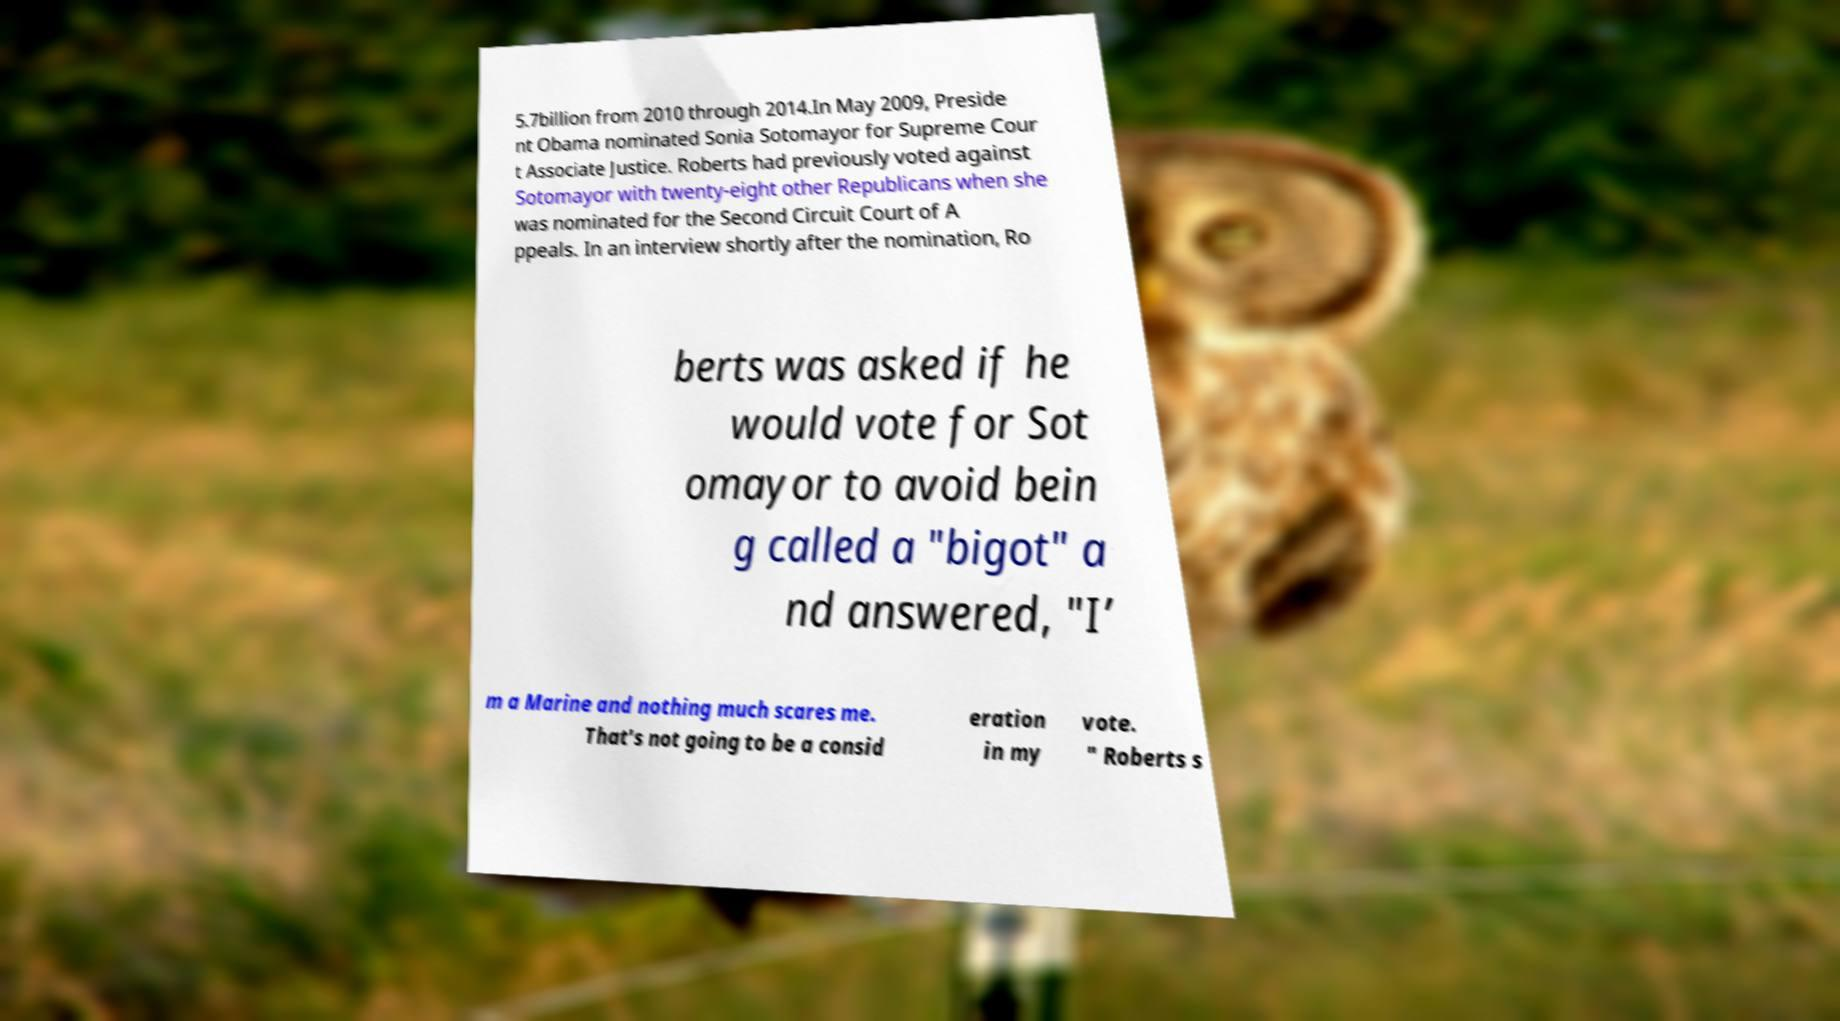Please read and relay the text visible in this image. What does it say? 5.7billion from 2010 through 2014.In May 2009, Preside nt Obama nominated Sonia Sotomayor for Supreme Cour t Associate Justice. Roberts had previously voted against Sotomayor with twenty-eight other Republicans when she was nominated for the Second Circuit Court of A ppeals. In an interview shortly after the nomination, Ro berts was asked if he would vote for Sot omayor to avoid bein g called a "bigot" a nd answered, "I’ m a Marine and nothing much scares me. That's not going to be a consid eration in my vote. " Roberts s 